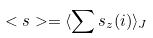Convert formula to latex. <formula><loc_0><loc_0><loc_500><loc_500>< s > = \langle \sum s _ { z } ( i ) \rangle _ { J }</formula> 